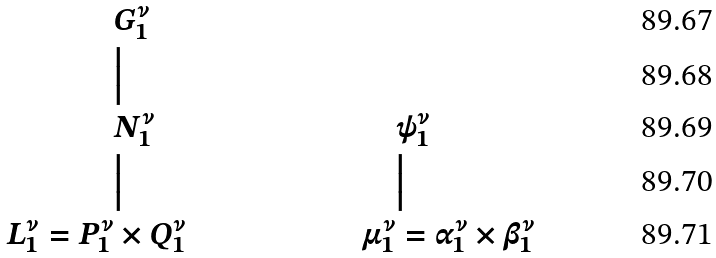Convert formula to latex. <formula><loc_0><loc_0><loc_500><loc_500>& G _ { 1 } ^ { \nu } & \quad & \\ & \Big | & & \\ & N _ { 1 } ^ { \nu } & & \psi _ { 1 } ^ { \nu } \\ & \Big | & & \Big | \\ L _ { 1 } ^ { \nu } = P _ { 1 } ^ { \nu } & \times Q _ { 1 } ^ { \nu } & \mu _ { 1 } ^ { \nu } & = \alpha _ { 1 } ^ { \nu } \times \beta _ { 1 } ^ { \nu }</formula> 